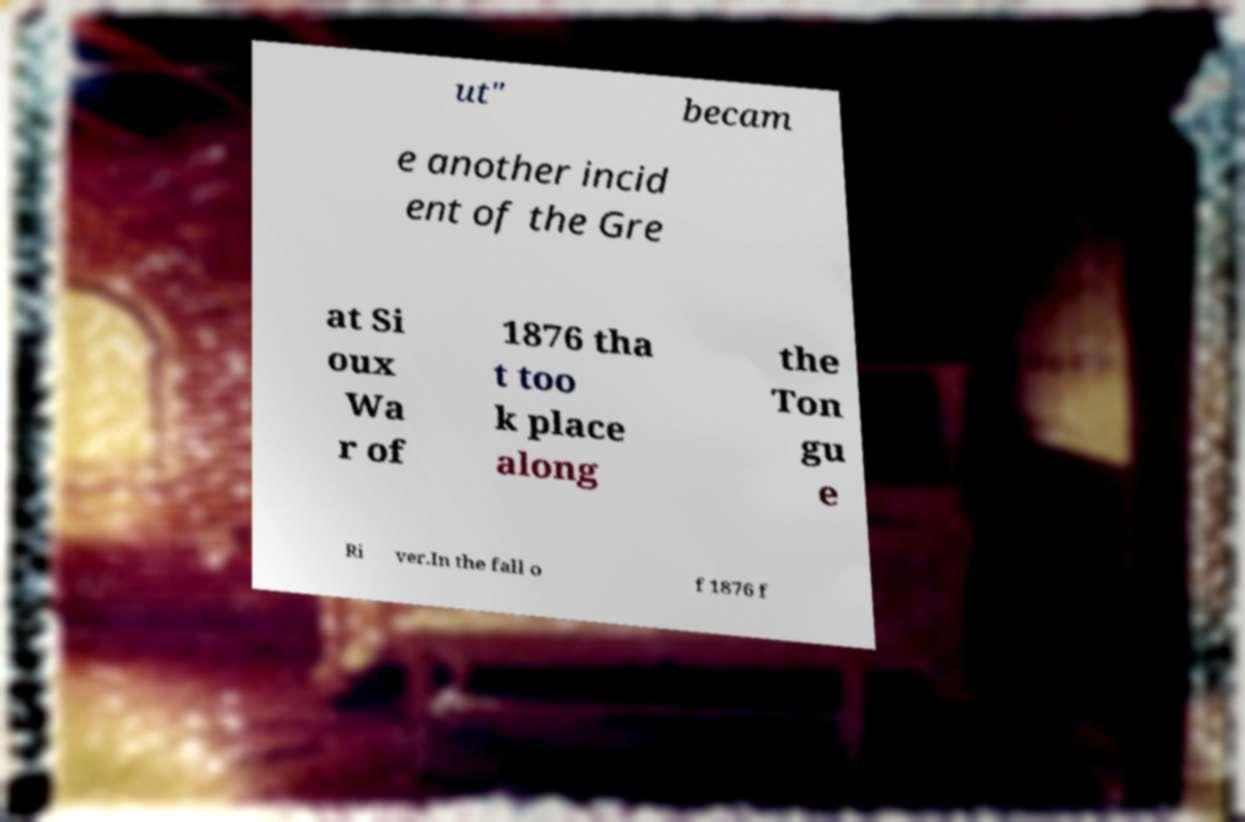Can you accurately transcribe the text from the provided image for me? ut" becam e another incid ent of the Gre at Si oux Wa r of 1876 tha t too k place along the Ton gu e Ri ver.In the fall o f 1876 f 